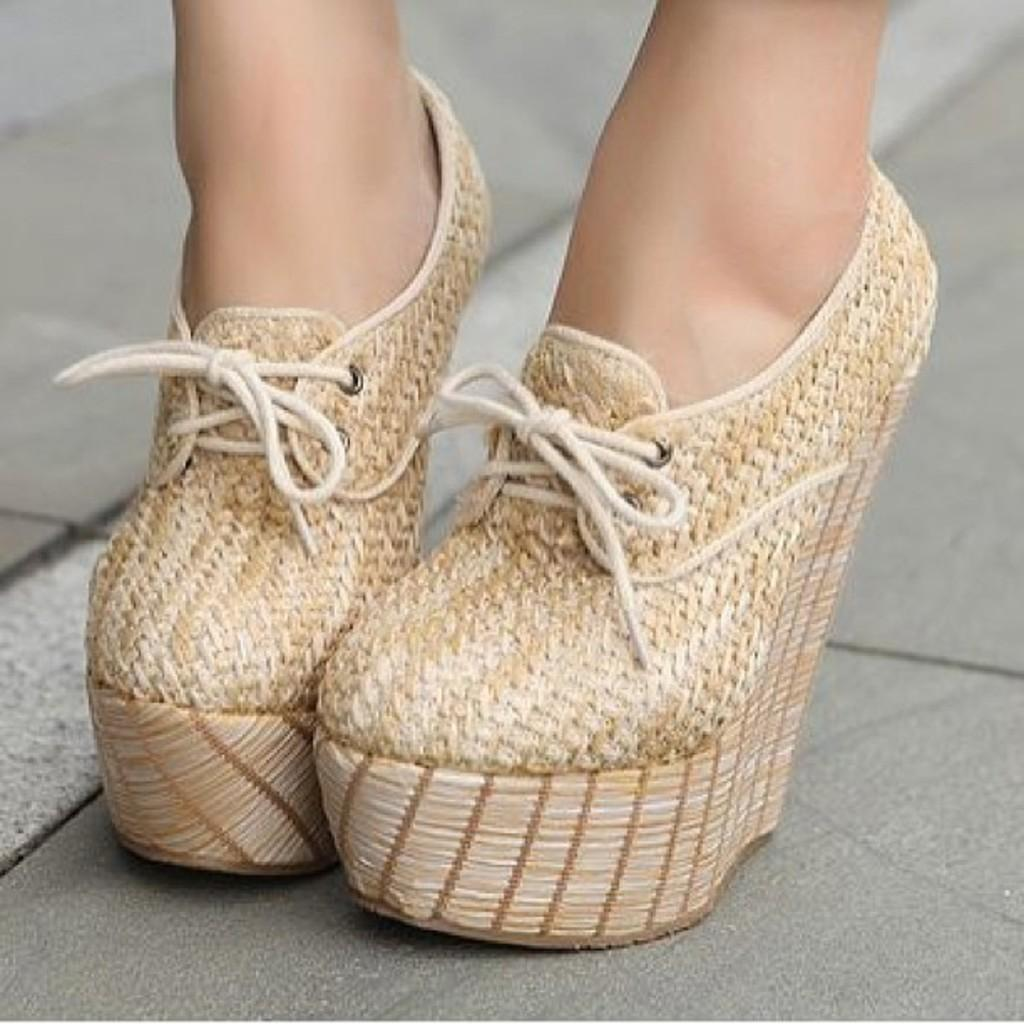What part of a person can be seen in the image? There are legs of a person visible in the image. What type of footwear is the person wearing? The person is wearing shoes. What surface is the person standing on in the image? The floor is visible in the image. What type of alley can be seen in the image? There is no alley present in the image; it only shows the legs of a person and the floor they are standing on. 